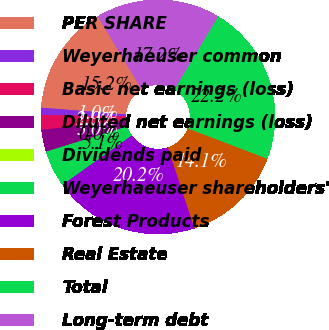Convert chart to OTSL. <chart><loc_0><loc_0><loc_500><loc_500><pie_chart><fcel>PER SHARE<fcel>Weyerhaeuser common<fcel>Basic net earnings (loss)<fcel>Diluted net earnings (loss)<fcel>Dividends paid<fcel>Weyerhaeuser shareholders'<fcel>Forest Products<fcel>Real Estate<fcel>Total<fcel>Long-term debt<nl><fcel>15.15%<fcel>1.01%<fcel>2.02%<fcel>3.03%<fcel>0.0%<fcel>5.05%<fcel>20.2%<fcel>14.14%<fcel>22.22%<fcel>17.17%<nl></chart> 